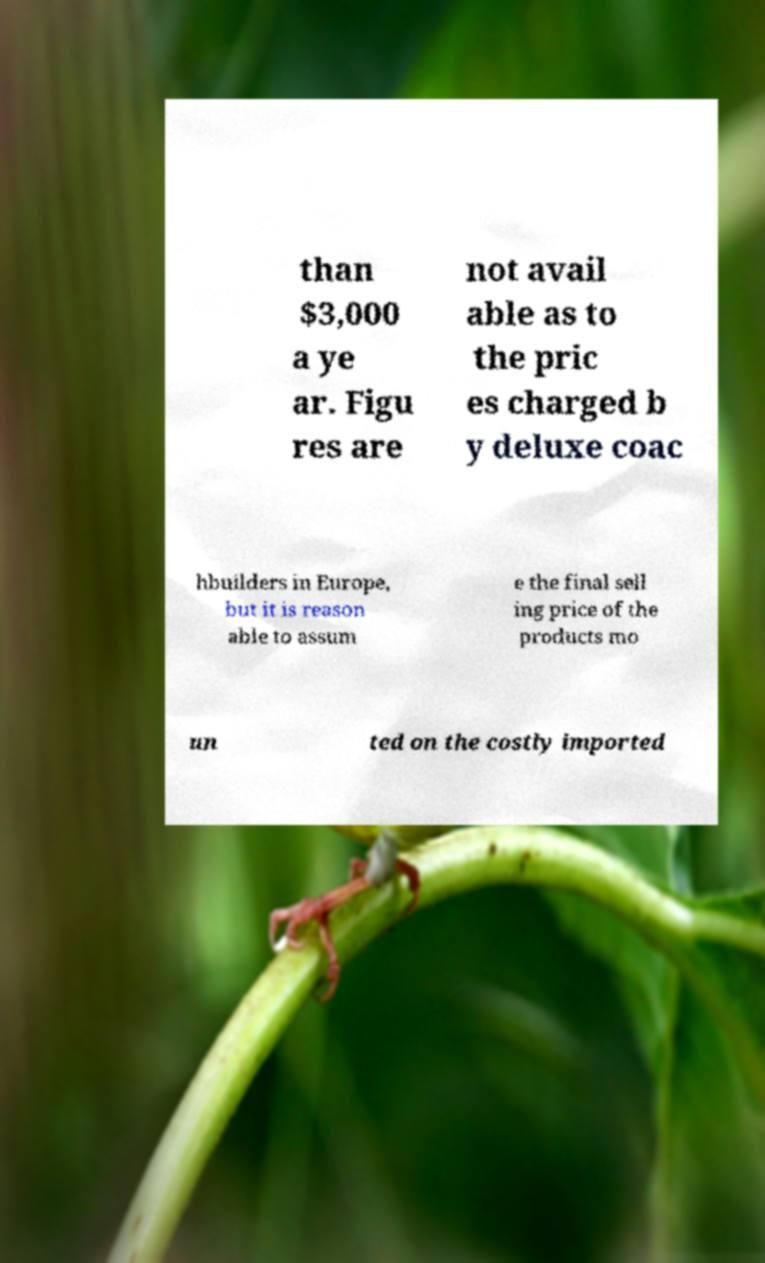What messages or text are displayed in this image? I need them in a readable, typed format. than $3,000 a ye ar. Figu res are not avail able as to the pric es charged b y deluxe coac hbuilders in Europe, but it is reason able to assum e the final sell ing price of the products mo un ted on the costly imported 